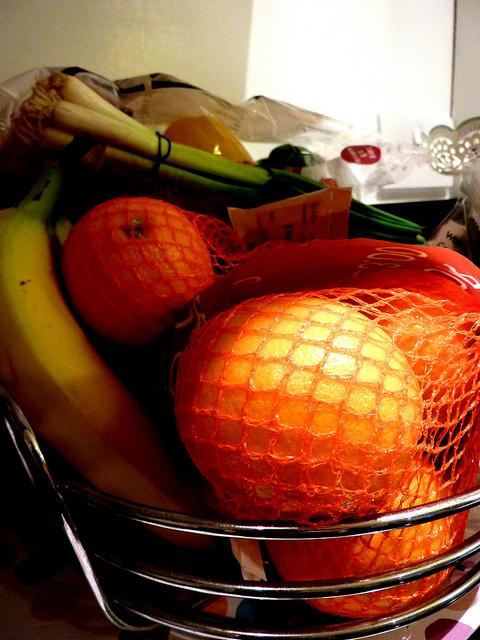What vegetable is bundled together?

Choices:
A) asparagus
B) broccoli
C) celery
D) onion onion 